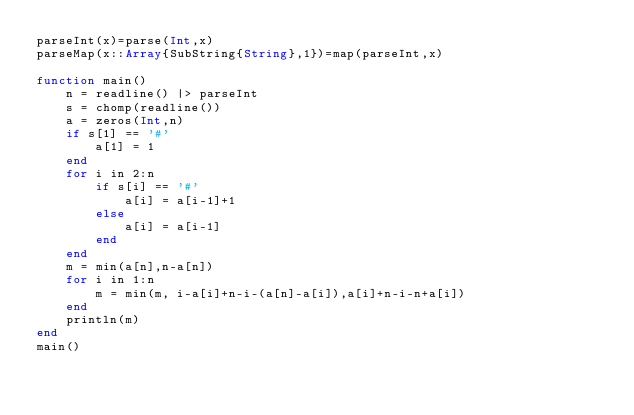<code> <loc_0><loc_0><loc_500><loc_500><_Julia_>parseInt(x)=parse(Int,x)
parseMap(x::Array{SubString{String},1})=map(parseInt,x)

function main()
	n = readline() |> parseInt
	s = chomp(readline())
	a = zeros(Int,n)
	if s[1] == '#'
		a[1] = 1
	end
	for i in 2:n
		if s[i] == '#'
			a[i] = a[i-1]+1
		else
			a[i] = a[i-1]
		end
	end
	m = min(a[n],n-a[n])
	for i in 1:n
		m = min(m, i-a[i]+n-i-(a[n]-a[i]),a[i]+n-i-n+a[i])
	end
	println(m)
end
main()
</code> 